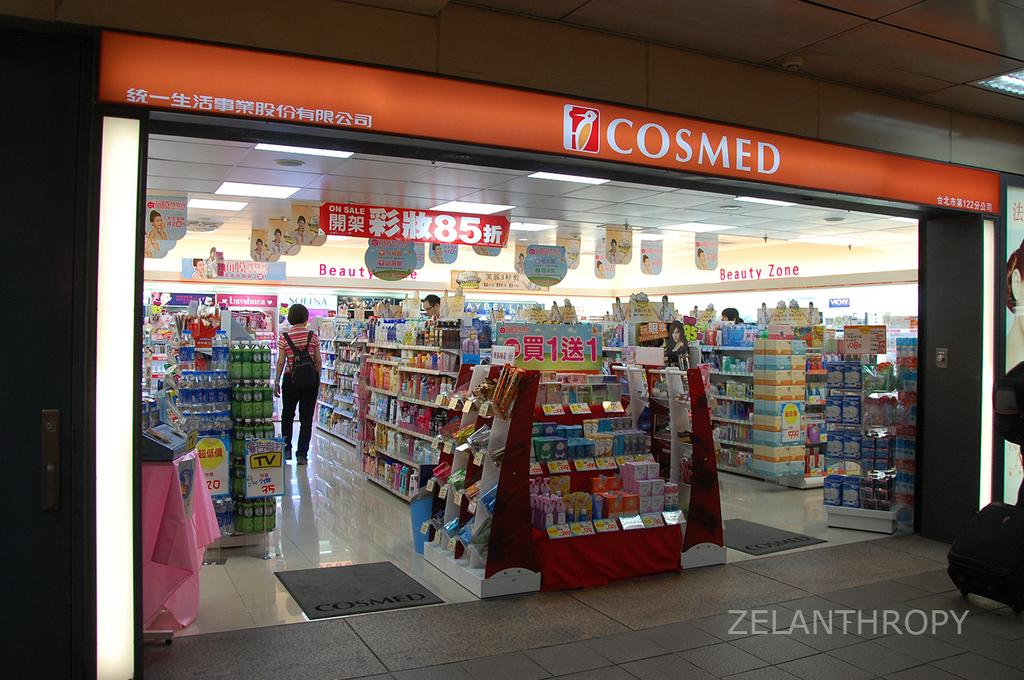<image>
Render a clear and concise summary of the photo. a store with an orange sign named cosmed 